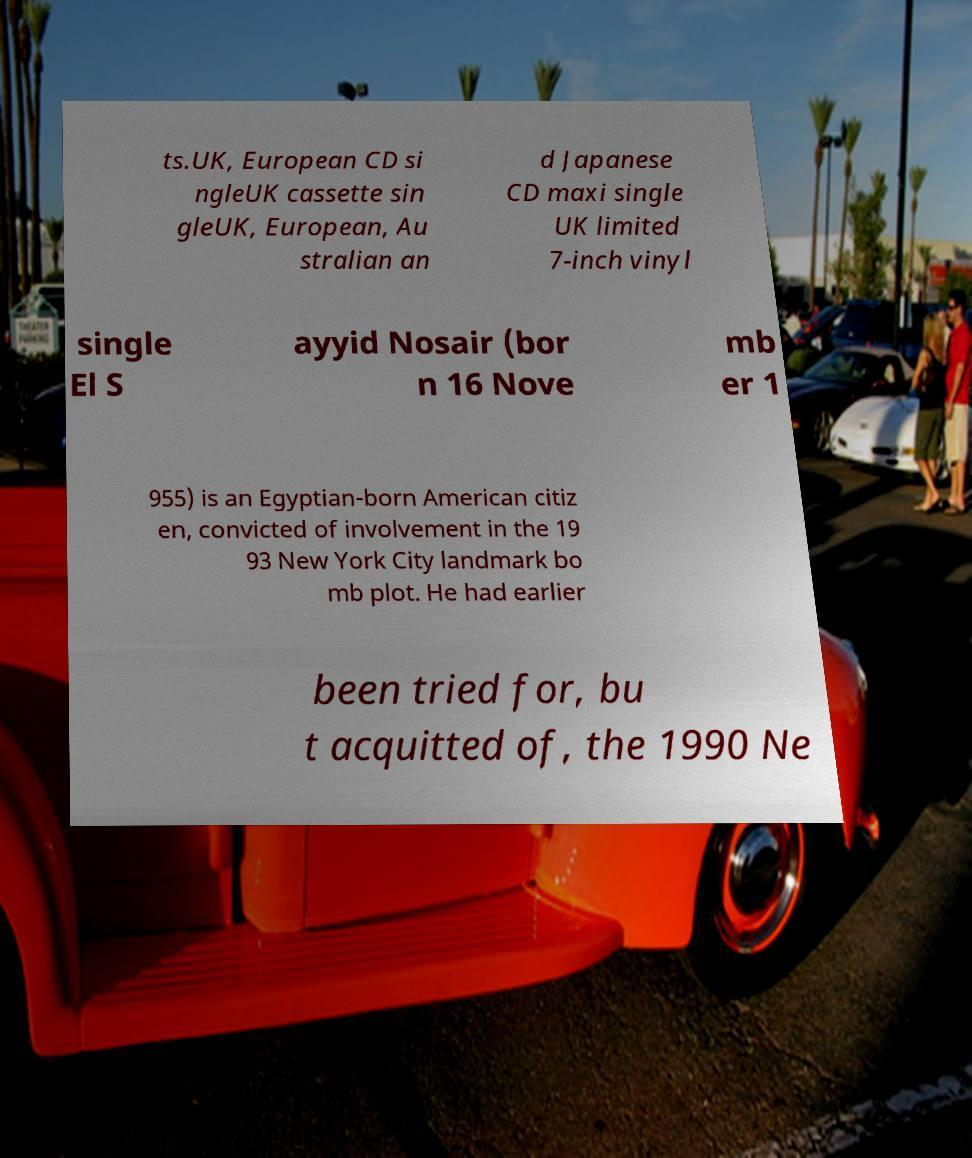There's text embedded in this image that I need extracted. Can you transcribe it verbatim? ts.UK, European CD si ngleUK cassette sin gleUK, European, Au stralian an d Japanese CD maxi single UK limited 7-inch vinyl single El S ayyid Nosair (bor n 16 Nove mb er 1 955) is an Egyptian-born American citiz en, convicted of involvement in the 19 93 New York City landmark bo mb plot. He had earlier been tried for, bu t acquitted of, the 1990 Ne 